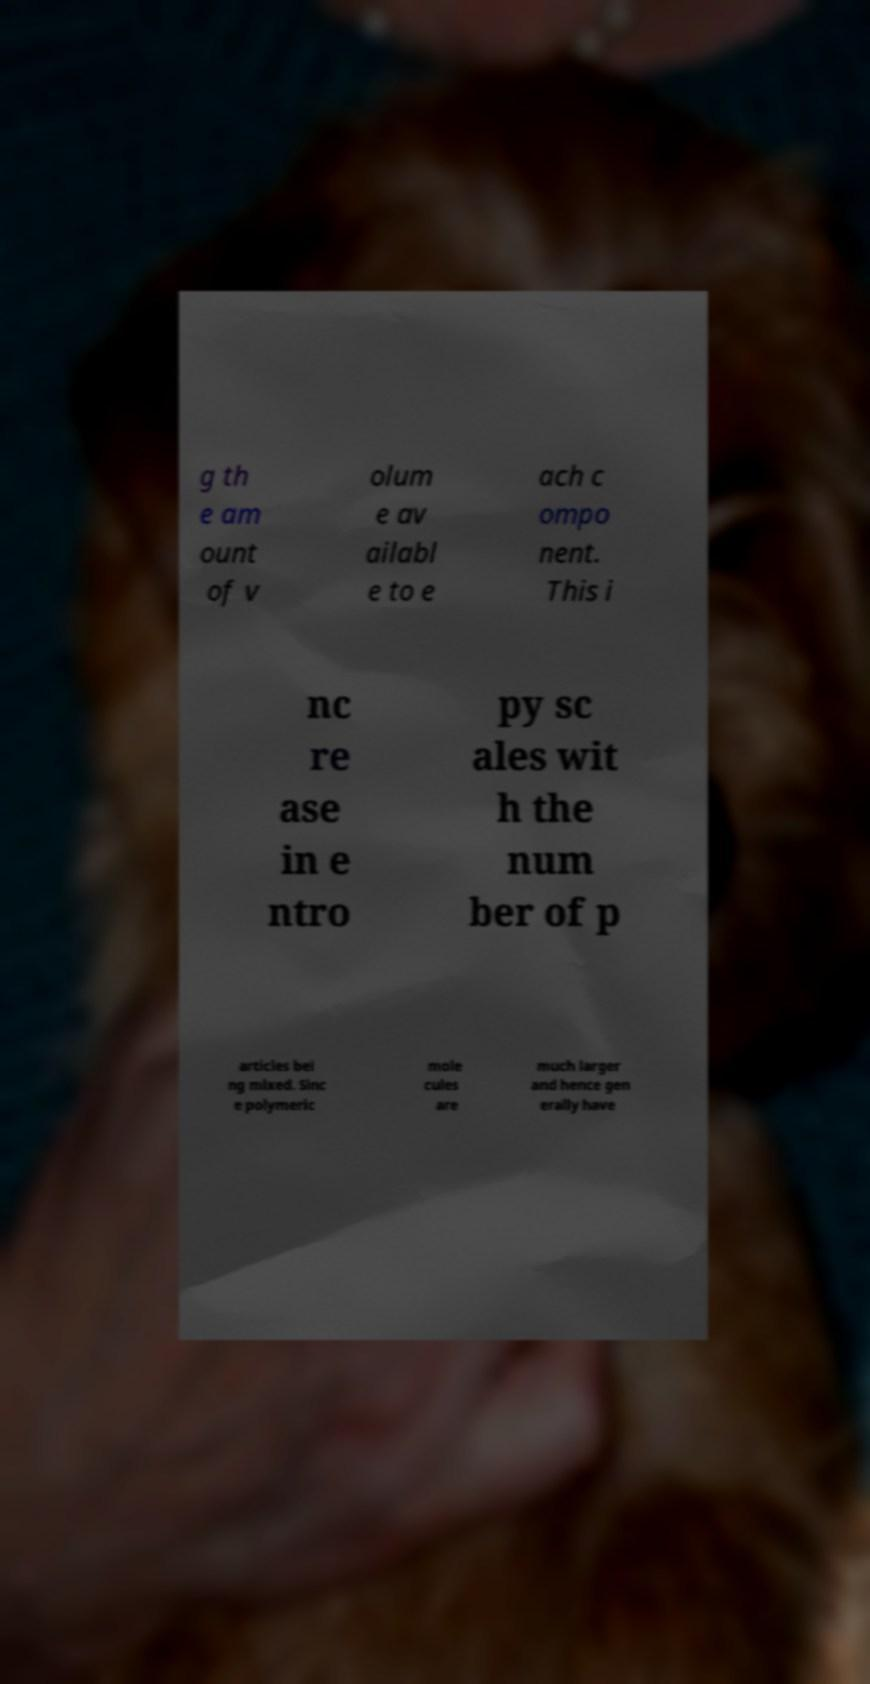There's text embedded in this image that I need extracted. Can you transcribe it verbatim? g th e am ount of v olum e av ailabl e to e ach c ompo nent. This i nc re ase in e ntro py sc ales wit h the num ber of p articles bei ng mixed. Sinc e polymeric mole cules are much larger and hence gen erally have 